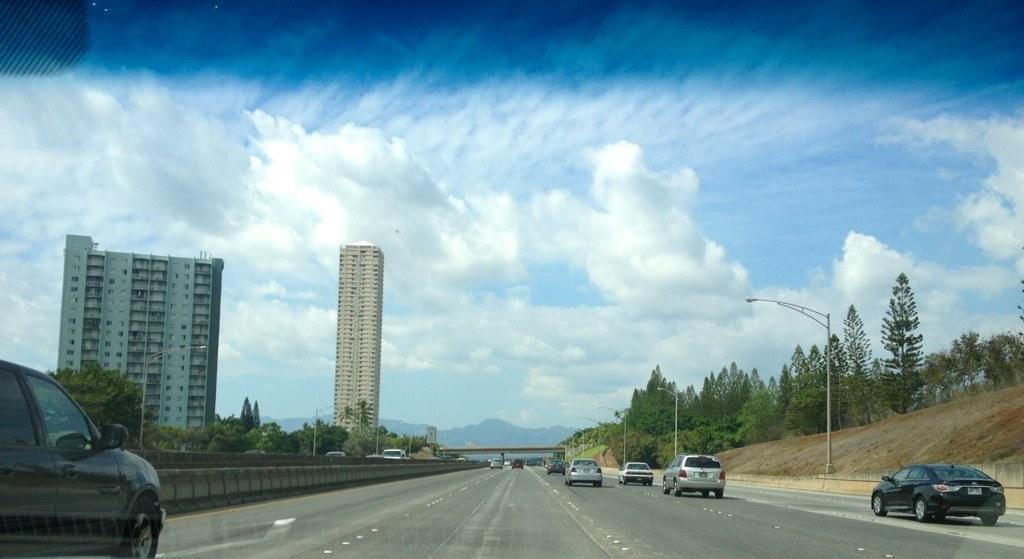Can you describe this image briefly? In the foreground of the picture there is a glass, outside the glass there are cars, on the road. On the left there are trees, street lights and buildings. On the right there are trees, street lights and soil. In the center of the background there are vehicles, bridge and hills. Sky is sunny. 